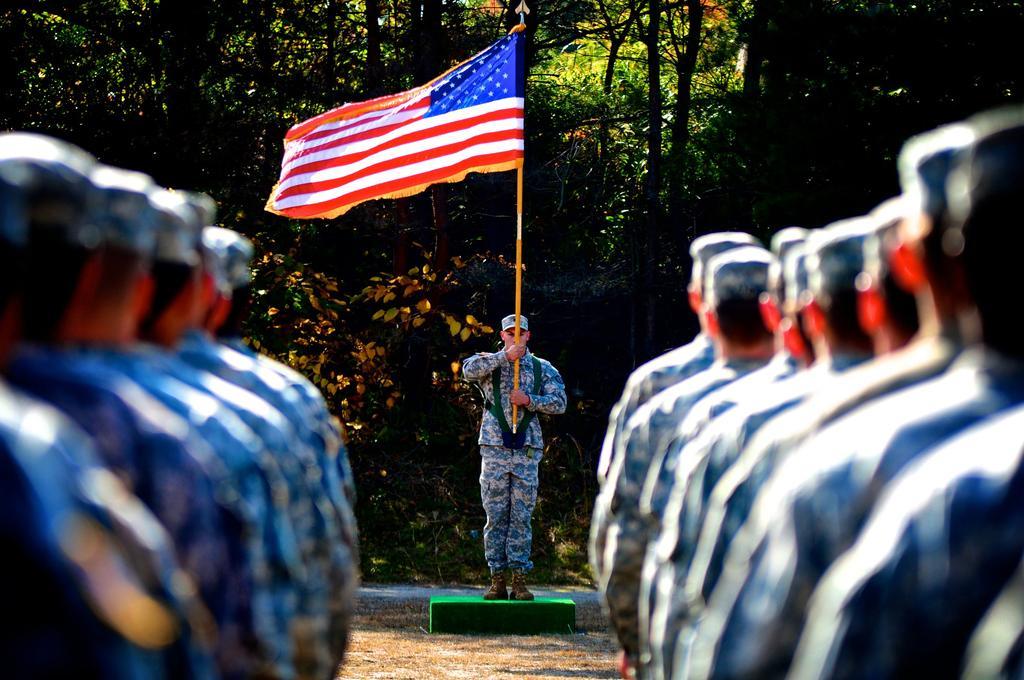Could you give a brief overview of what you see in this image? In this image we can see a few people standing in the line, in front them, we can see a another person standing and holding a flag, in the background we can see the trees. 